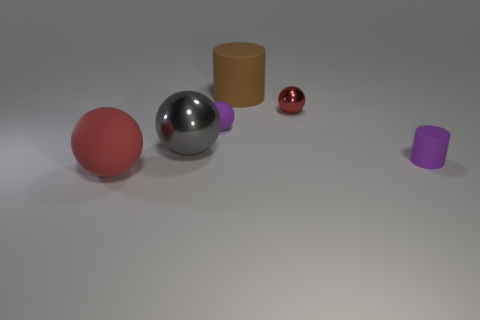How do the sizes of the objects compare with each other? The objects exhibit a diverse range of sizes – the red sphere is the largest, followed by the silver sphere. The brown cylinder and purple cylinder are smaller, with the brown one being taller yet narrower. The smallest object is the red-orange sphere, with its size discernibly smaller than the others. 